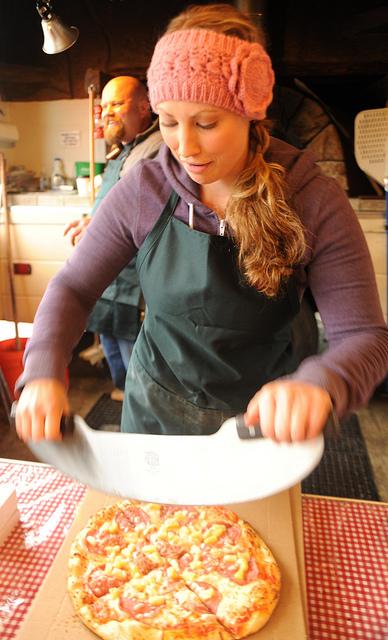What color is the lady's headband?
Concise answer only. Pink. What is the woman doing?
Concise answer only. Cutting pizza. What is the lady making?
Keep it brief. Pizza. Is the person dressed as a chef?
Keep it brief. No. Where is the blue scarf?
Quick response, please. Nowhere. What colors make up the girl's hat?
Give a very brief answer. Pink. What is the name of the type of knife the chef is using?
Keep it brief. Rocker knife. Has any of the pizza shown been eaten?
Answer briefly. No. What kind of pizza is she eating?
Write a very short answer. Cheese. 